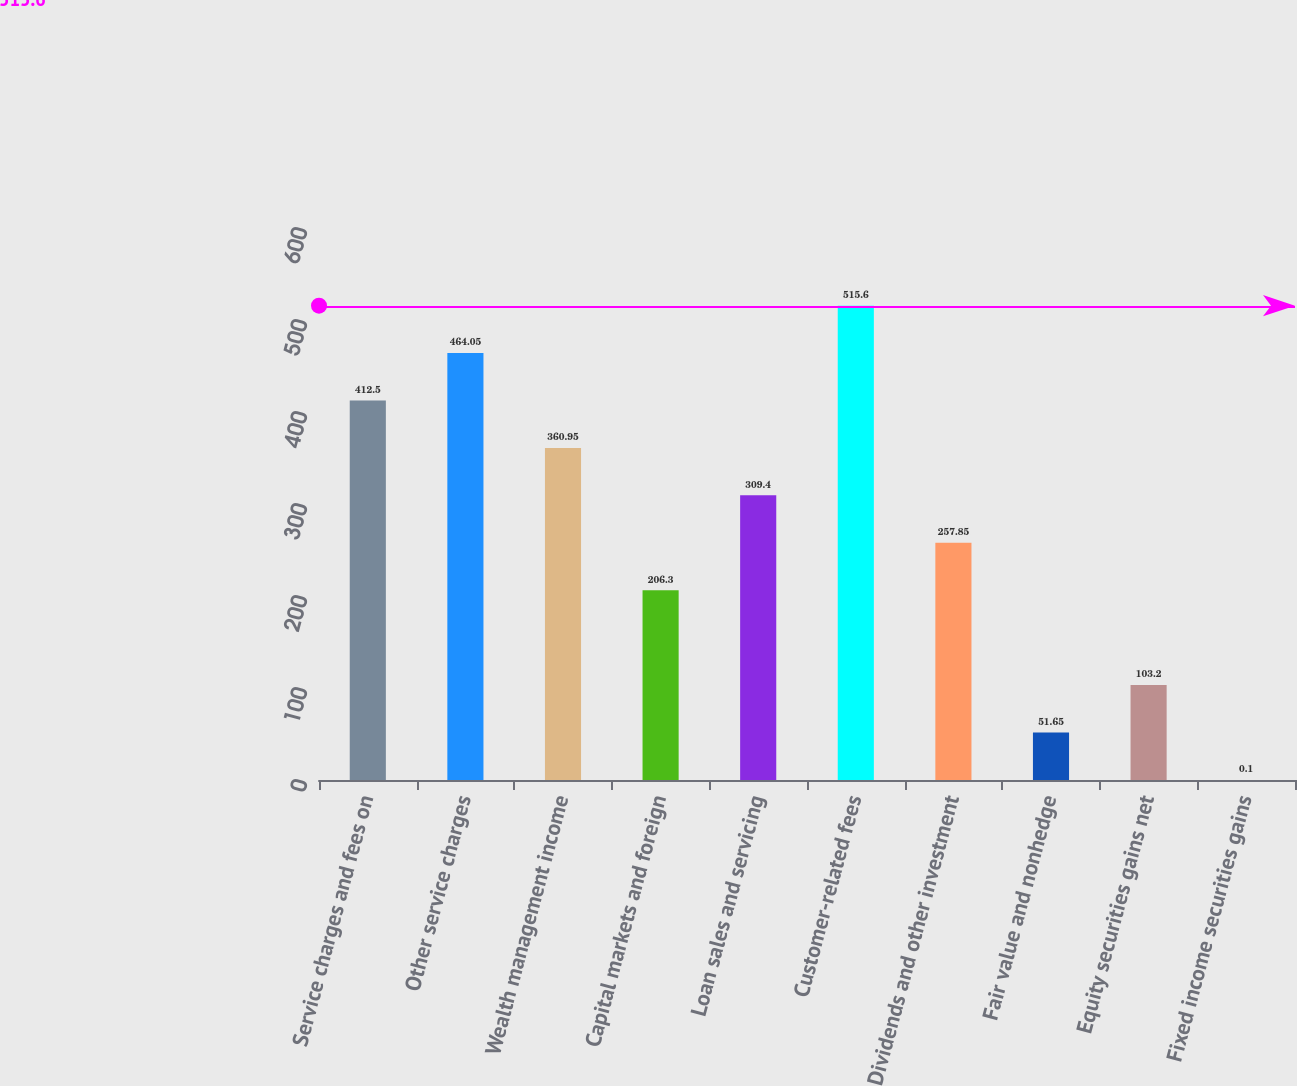Convert chart. <chart><loc_0><loc_0><loc_500><loc_500><bar_chart><fcel>Service charges and fees on<fcel>Other service charges<fcel>Wealth management income<fcel>Capital markets and foreign<fcel>Loan sales and servicing<fcel>Customer-related fees<fcel>Dividends and other investment<fcel>Fair value and nonhedge<fcel>Equity securities gains net<fcel>Fixed income securities gains<nl><fcel>412.5<fcel>464.05<fcel>360.95<fcel>206.3<fcel>309.4<fcel>515.6<fcel>257.85<fcel>51.65<fcel>103.2<fcel>0.1<nl></chart> 